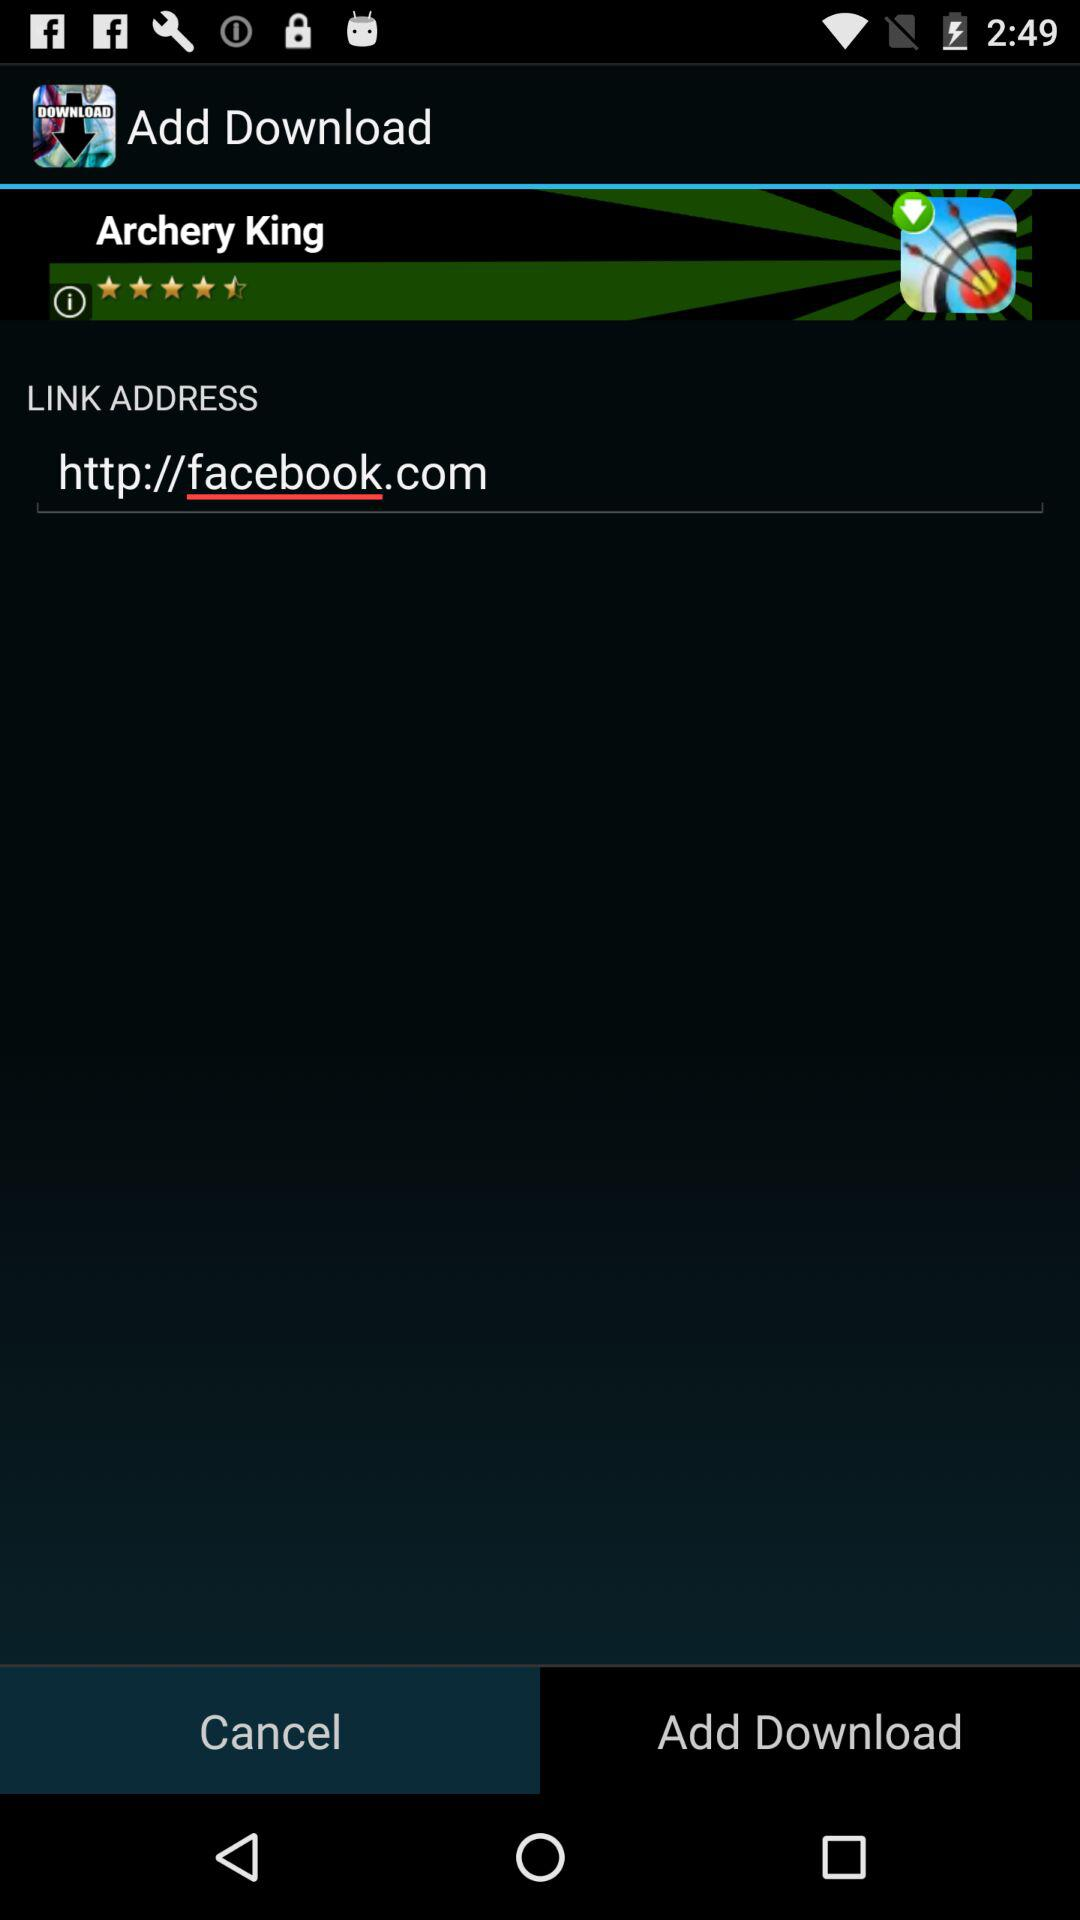What is the link address? The link address is http://facebook.com. 